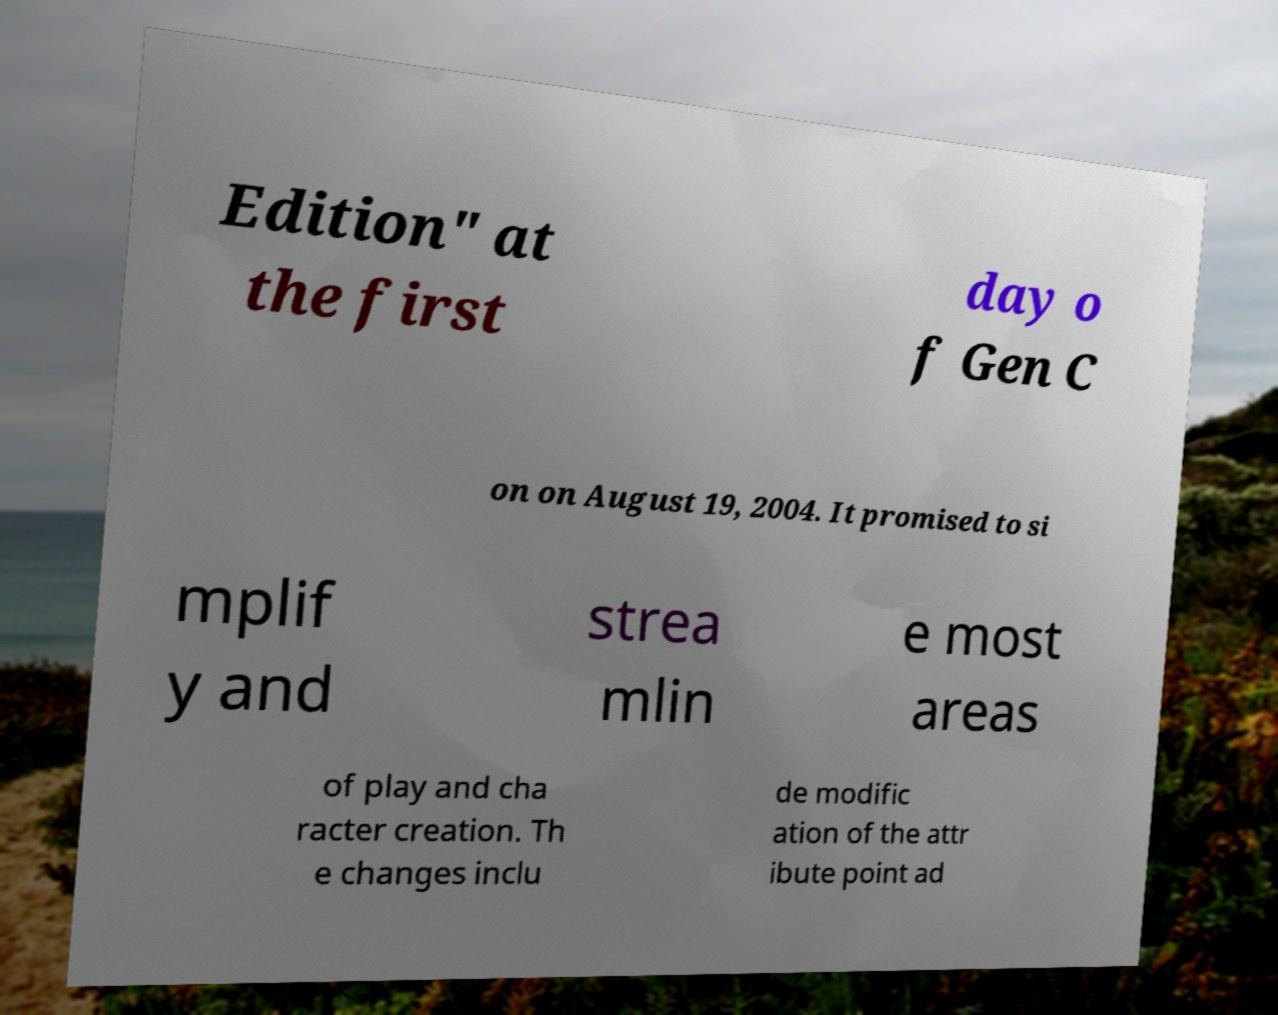For documentation purposes, I need the text within this image transcribed. Could you provide that? Edition" at the first day o f Gen C on on August 19, 2004. It promised to si mplif y and strea mlin e most areas of play and cha racter creation. Th e changes inclu de modific ation of the attr ibute point ad 